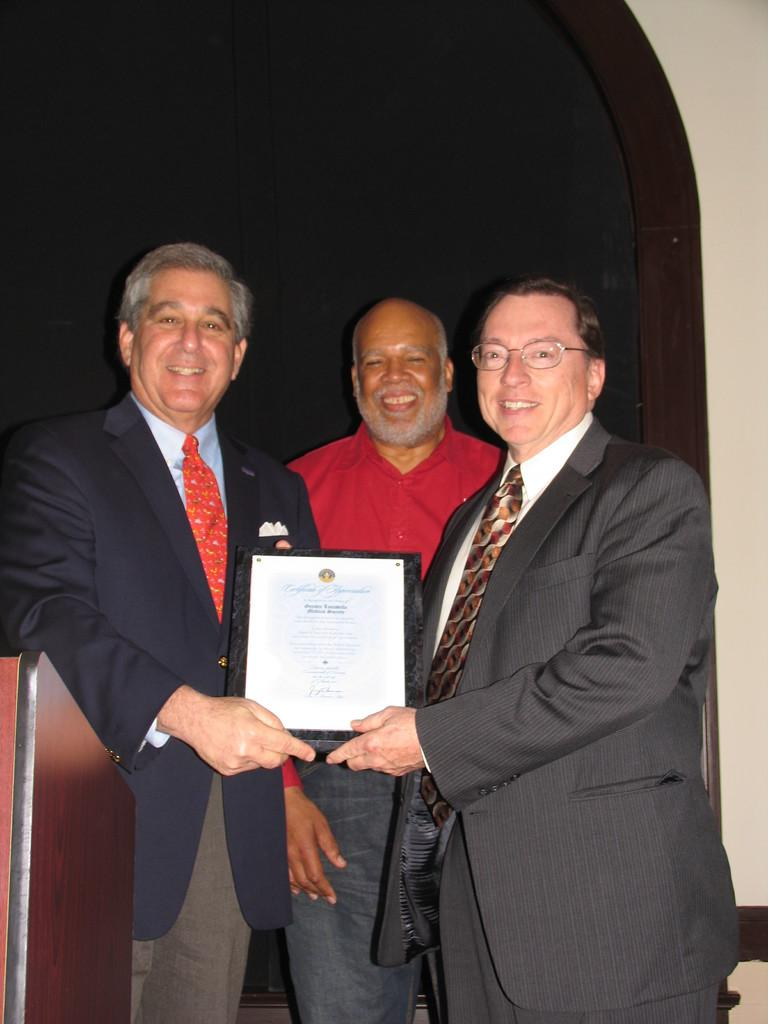How many people are present in the image? There are three people in the image. What are two of the people holding? Two of the people are holding a certificate. Can you describe the background of the image? The background of the image is darker. What type of poison is being used by the people in the image? There is no poison present in the image; the people are holding a certificate. What color are the stockings worn by the people in the image? There is no mention of stockings in the image, so we cannot determine their color. 